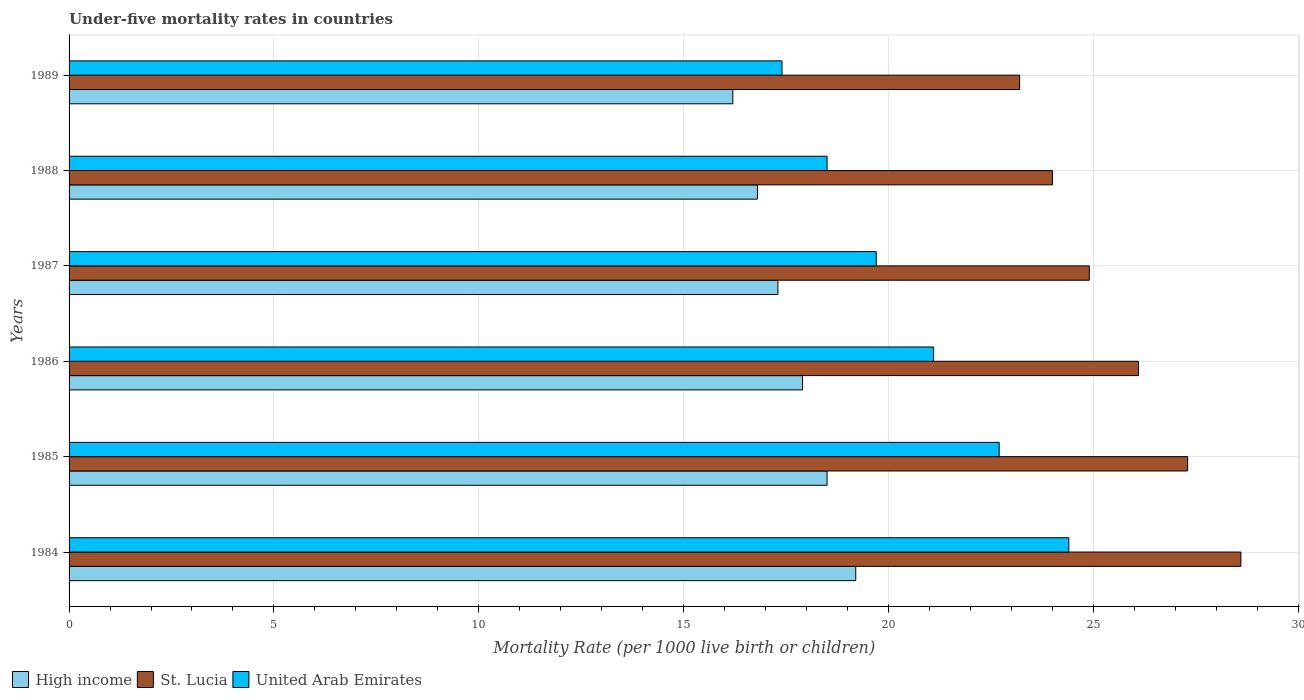Are the number of bars per tick equal to the number of legend labels?
Offer a terse response. Yes. Are the number of bars on each tick of the Y-axis equal?
Offer a very short reply. Yes. How many bars are there on the 4th tick from the top?
Ensure brevity in your answer.  3. In how many cases, is the number of bars for a given year not equal to the number of legend labels?
Your response must be concise. 0. Across all years, what is the maximum under-five mortality rate in St. Lucia?
Your answer should be very brief. 28.6. Across all years, what is the minimum under-five mortality rate in St. Lucia?
Make the answer very short. 23.2. In which year was the under-five mortality rate in High income maximum?
Ensure brevity in your answer.  1984. In which year was the under-five mortality rate in High income minimum?
Provide a succinct answer. 1989. What is the total under-five mortality rate in High income in the graph?
Give a very brief answer. 105.9. What is the difference between the under-five mortality rate in United Arab Emirates in 1986 and that in 1988?
Offer a terse response. 2.6. What is the difference between the under-five mortality rate in St. Lucia in 1987 and the under-five mortality rate in United Arab Emirates in 1988?
Your response must be concise. 6.4. What is the average under-five mortality rate in High income per year?
Keep it short and to the point. 17.65. In the year 1989, what is the difference between the under-five mortality rate in United Arab Emirates and under-five mortality rate in St. Lucia?
Provide a succinct answer. -5.8. In how many years, is the under-five mortality rate in St. Lucia greater than 7 ?
Provide a succinct answer. 6. What is the ratio of the under-five mortality rate in United Arab Emirates in 1984 to that in 1986?
Your answer should be very brief. 1.16. Is the under-five mortality rate in High income in 1984 less than that in 1989?
Your answer should be compact. No. Is the difference between the under-five mortality rate in United Arab Emirates in 1985 and 1988 greater than the difference between the under-five mortality rate in St. Lucia in 1985 and 1988?
Your answer should be compact. Yes. What is the difference between the highest and the second highest under-five mortality rate in High income?
Keep it short and to the point. 0.7. In how many years, is the under-five mortality rate in St. Lucia greater than the average under-five mortality rate in St. Lucia taken over all years?
Provide a short and direct response. 3. Is the sum of the under-five mortality rate in St. Lucia in 1984 and 1986 greater than the maximum under-five mortality rate in United Arab Emirates across all years?
Give a very brief answer. Yes. What does the 1st bar from the top in 1984 represents?
Offer a very short reply. United Arab Emirates. Is it the case that in every year, the sum of the under-five mortality rate in St. Lucia and under-five mortality rate in High income is greater than the under-five mortality rate in United Arab Emirates?
Make the answer very short. Yes. What is the difference between two consecutive major ticks on the X-axis?
Offer a terse response. 5. Does the graph contain any zero values?
Ensure brevity in your answer.  No. Does the graph contain grids?
Provide a succinct answer. Yes. Where does the legend appear in the graph?
Your answer should be compact. Bottom left. How are the legend labels stacked?
Keep it short and to the point. Horizontal. What is the title of the graph?
Keep it short and to the point. Under-five mortality rates in countries. What is the label or title of the X-axis?
Your response must be concise. Mortality Rate (per 1000 live birth or children). What is the label or title of the Y-axis?
Provide a short and direct response. Years. What is the Mortality Rate (per 1000 live birth or children) in St. Lucia in 1984?
Give a very brief answer. 28.6. What is the Mortality Rate (per 1000 live birth or children) in United Arab Emirates in 1984?
Your answer should be compact. 24.4. What is the Mortality Rate (per 1000 live birth or children) of St. Lucia in 1985?
Your answer should be compact. 27.3. What is the Mortality Rate (per 1000 live birth or children) of United Arab Emirates in 1985?
Keep it short and to the point. 22.7. What is the Mortality Rate (per 1000 live birth or children) of St. Lucia in 1986?
Offer a very short reply. 26.1. What is the Mortality Rate (per 1000 live birth or children) in United Arab Emirates in 1986?
Offer a terse response. 21.1. What is the Mortality Rate (per 1000 live birth or children) in St. Lucia in 1987?
Provide a succinct answer. 24.9. What is the Mortality Rate (per 1000 live birth or children) of St. Lucia in 1989?
Ensure brevity in your answer.  23.2. What is the Mortality Rate (per 1000 live birth or children) of United Arab Emirates in 1989?
Make the answer very short. 17.4. Across all years, what is the maximum Mortality Rate (per 1000 live birth or children) in High income?
Offer a very short reply. 19.2. Across all years, what is the maximum Mortality Rate (per 1000 live birth or children) of St. Lucia?
Make the answer very short. 28.6. Across all years, what is the maximum Mortality Rate (per 1000 live birth or children) of United Arab Emirates?
Keep it short and to the point. 24.4. Across all years, what is the minimum Mortality Rate (per 1000 live birth or children) of St. Lucia?
Offer a terse response. 23.2. Across all years, what is the minimum Mortality Rate (per 1000 live birth or children) of United Arab Emirates?
Make the answer very short. 17.4. What is the total Mortality Rate (per 1000 live birth or children) in High income in the graph?
Provide a succinct answer. 105.9. What is the total Mortality Rate (per 1000 live birth or children) in St. Lucia in the graph?
Give a very brief answer. 154.1. What is the total Mortality Rate (per 1000 live birth or children) of United Arab Emirates in the graph?
Make the answer very short. 123.8. What is the difference between the Mortality Rate (per 1000 live birth or children) of United Arab Emirates in 1984 and that in 1985?
Provide a short and direct response. 1.7. What is the difference between the Mortality Rate (per 1000 live birth or children) in High income in 1984 and that in 1986?
Offer a terse response. 1.3. What is the difference between the Mortality Rate (per 1000 live birth or children) of United Arab Emirates in 1984 and that in 1986?
Keep it short and to the point. 3.3. What is the difference between the Mortality Rate (per 1000 live birth or children) in St. Lucia in 1984 and that in 1987?
Your answer should be very brief. 3.7. What is the difference between the Mortality Rate (per 1000 live birth or children) in High income in 1984 and that in 1988?
Give a very brief answer. 2.4. What is the difference between the Mortality Rate (per 1000 live birth or children) in High income in 1984 and that in 1989?
Make the answer very short. 3. What is the difference between the Mortality Rate (per 1000 live birth or children) of High income in 1985 and that in 1986?
Give a very brief answer. 0.6. What is the difference between the Mortality Rate (per 1000 live birth or children) of St. Lucia in 1985 and that in 1986?
Ensure brevity in your answer.  1.2. What is the difference between the Mortality Rate (per 1000 live birth or children) of High income in 1985 and that in 1987?
Offer a very short reply. 1.2. What is the difference between the Mortality Rate (per 1000 live birth or children) of St. Lucia in 1985 and that in 1987?
Offer a terse response. 2.4. What is the difference between the Mortality Rate (per 1000 live birth or children) in United Arab Emirates in 1985 and that in 1987?
Your answer should be compact. 3. What is the difference between the Mortality Rate (per 1000 live birth or children) of High income in 1985 and that in 1988?
Give a very brief answer. 1.7. What is the difference between the Mortality Rate (per 1000 live birth or children) in St. Lucia in 1985 and that in 1988?
Provide a short and direct response. 3.3. What is the difference between the Mortality Rate (per 1000 live birth or children) of United Arab Emirates in 1985 and that in 1988?
Give a very brief answer. 4.2. What is the difference between the Mortality Rate (per 1000 live birth or children) of High income in 1985 and that in 1989?
Provide a short and direct response. 2.3. What is the difference between the Mortality Rate (per 1000 live birth or children) in United Arab Emirates in 1985 and that in 1989?
Your answer should be very brief. 5.3. What is the difference between the Mortality Rate (per 1000 live birth or children) in High income in 1986 and that in 1987?
Ensure brevity in your answer.  0.6. What is the difference between the Mortality Rate (per 1000 live birth or children) of St. Lucia in 1986 and that in 1987?
Offer a terse response. 1.2. What is the difference between the Mortality Rate (per 1000 live birth or children) of United Arab Emirates in 1986 and that in 1987?
Your answer should be very brief. 1.4. What is the difference between the Mortality Rate (per 1000 live birth or children) of St. Lucia in 1986 and that in 1988?
Provide a succinct answer. 2.1. What is the difference between the Mortality Rate (per 1000 live birth or children) of High income in 1986 and that in 1989?
Keep it short and to the point. 1.7. What is the difference between the Mortality Rate (per 1000 live birth or children) of United Arab Emirates in 1986 and that in 1989?
Ensure brevity in your answer.  3.7. What is the difference between the Mortality Rate (per 1000 live birth or children) in St. Lucia in 1987 and that in 1988?
Provide a succinct answer. 0.9. What is the difference between the Mortality Rate (per 1000 live birth or children) in United Arab Emirates in 1987 and that in 1988?
Provide a succinct answer. 1.2. What is the difference between the Mortality Rate (per 1000 live birth or children) in High income in 1984 and the Mortality Rate (per 1000 live birth or children) in United Arab Emirates in 1985?
Give a very brief answer. -3.5. What is the difference between the Mortality Rate (per 1000 live birth or children) in St. Lucia in 1984 and the Mortality Rate (per 1000 live birth or children) in United Arab Emirates in 1985?
Provide a short and direct response. 5.9. What is the difference between the Mortality Rate (per 1000 live birth or children) of High income in 1984 and the Mortality Rate (per 1000 live birth or children) of United Arab Emirates in 1986?
Provide a succinct answer. -1.9. What is the difference between the Mortality Rate (per 1000 live birth or children) in St. Lucia in 1984 and the Mortality Rate (per 1000 live birth or children) in United Arab Emirates in 1986?
Your answer should be compact. 7.5. What is the difference between the Mortality Rate (per 1000 live birth or children) in High income in 1984 and the Mortality Rate (per 1000 live birth or children) in St. Lucia in 1987?
Ensure brevity in your answer.  -5.7. What is the difference between the Mortality Rate (per 1000 live birth or children) in High income in 1984 and the Mortality Rate (per 1000 live birth or children) in United Arab Emirates in 1987?
Make the answer very short. -0.5. What is the difference between the Mortality Rate (per 1000 live birth or children) of St. Lucia in 1984 and the Mortality Rate (per 1000 live birth or children) of United Arab Emirates in 1987?
Ensure brevity in your answer.  8.9. What is the difference between the Mortality Rate (per 1000 live birth or children) in High income in 1984 and the Mortality Rate (per 1000 live birth or children) in St. Lucia in 1988?
Your answer should be compact. -4.8. What is the difference between the Mortality Rate (per 1000 live birth or children) in High income in 1984 and the Mortality Rate (per 1000 live birth or children) in St. Lucia in 1989?
Make the answer very short. -4. What is the difference between the Mortality Rate (per 1000 live birth or children) in High income in 1984 and the Mortality Rate (per 1000 live birth or children) in United Arab Emirates in 1989?
Give a very brief answer. 1.8. What is the difference between the Mortality Rate (per 1000 live birth or children) in St. Lucia in 1984 and the Mortality Rate (per 1000 live birth or children) in United Arab Emirates in 1989?
Offer a very short reply. 11.2. What is the difference between the Mortality Rate (per 1000 live birth or children) in High income in 1985 and the Mortality Rate (per 1000 live birth or children) in St. Lucia in 1986?
Provide a succinct answer. -7.6. What is the difference between the Mortality Rate (per 1000 live birth or children) in High income in 1985 and the Mortality Rate (per 1000 live birth or children) in United Arab Emirates in 1987?
Your answer should be very brief. -1.2. What is the difference between the Mortality Rate (per 1000 live birth or children) of St. Lucia in 1985 and the Mortality Rate (per 1000 live birth or children) of United Arab Emirates in 1987?
Give a very brief answer. 7.6. What is the difference between the Mortality Rate (per 1000 live birth or children) of High income in 1985 and the Mortality Rate (per 1000 live birth or children) of St. Lucia in 1988?
Keep it short and to the point. -5.5. What is the difference between the Mortality Rate (per 1000 live birth or children) of St. Lucia in 1985 and the Mortality Rate (per 1000 live birth or children) of United Arab Emirates in 1988?
Offer a terse response. 8.8. What is the difference between the Mortality Rate (per 1000 live birth or children) of High income in 1985 and the Mortality Rate (per 1000 live birth or children) of St. Lucia in 1989?
Offer a very short reply. -4.7. What is the difference between the Mortality Rate (per 1000 live birth or children) in St. Lucia in 1985 and the Mortality Rate (per 1000 live birth or children) in United Arab Emirates in 1989?
Offer a very short reply. 9.9. What is the difference between the Mortality Rate (per 1000 live birth or children) in High income in 1986 and the Mortality Rate (per 1000 live birth or children) in St. Lucia in 1987?
Make the answer very short. -7. What is the difference between the Mortality Rate (per 1000 live birth or children) of High income in 1986 and the Mortality Rate (per 1000 live birth or children) of United Arab Emirates in 1987?
Provide a short and direct response. -1.8. What is the difference between the Mortality Rate (per 1000 live birth or children) of High income in 1986 and the Mortality Rate (per 1000 live birth or children) of St. Lucia in 1988?
Make the answer very short. -6.1. What is the difference between the Mortality Rate (per 1000 live birth or children) in St. Lucia in 1986 and the Mortality Rate (per 1000 live birth or children) in United Arab Emirates in 1988?
Offer a very short reply. 7.6. What is the difference between the Mortality Rate (per 1000 live birth or children) of St. Lucia in 1986 and the Mortality Rate (per 1000 live birth or children) of United Arab Emirates in 1989?
Provide a short and direct response. 8.7. What is the difference between the Mortality Rate (per 1000 live birth or children) in High income in 1987 and the Mortality Rate (per 1000 live birth or children) in St. Lucia in 1988?
Make the answer very short. -6.7. What is the difference between the Mortality Rate (per 1000 live birth or children) of High income in 1987 and the Mortality Rate (per 1000 live birth or children) of United Arab Emirates in 1988?
Give a very brief answer. -1.2. What is the difference between the Mortality Rate (per 1000 live birth or children) of St. Lucia in 1987 and the Mortality Rate (per 1000 live birth or children) of United Arab Emirates in 1989?
Your answer should be compact. 7.5. What is the difference between the Mortality Rate (per 1000 live birth or children) of High income in 1988 and the Mortality Rate (per 1000 live birth or children) of United Arab Emirates in 1989?
Offer a terse response. -0.6. What is the difference between the Mortality Rate (per 1000 live birth or children) of St. Lucia in 1988 and the Mortality Rate (per 1000 live birth or children) of United Arab Emirates in 1989?
Ensure brevity in your answer.  6.6. What is the average Mortality Rate (per 1000 live birth or children) of High income per year?
Offer a very short reply. 17.65. What is the average Mortality Rate (per 1000 live birth or children) of St. Lucia per year?
Your answer should be very brief. 25.68. What is the average Mortality Rate (per 1000 live birth or children) of United Arab Emirates per year?
Provide a succinct answer. 20.63. In the year 1984, what is the difference between the Mortality Rate (per 1000 live birth or children) of High income and Mortality Rate (per 1000 live birth or children) of St. Lucia?
Provide a succinct answer. -9.4. In the year 1985, what is the difference between the Mortality Rate (per 1000 live birth or children) of St. Lucia and Mortality Rate (per 1000 live birth or children) of United Arab Emirates?
Provide a short and direct response. 4.6. In the year 1986, what is the difference between the Mortality Rate (per 1000 live birth or children) in High income and Mortality Rate (per 1000 live birth or children) in St. Lucia?
Offer a terse response. -8.2. In the year 1986, what is the difference between the Mortality Rate (per 1000 live birth or children) of St. Lucia and Mortality Rate (per 1000 live birth or children) of United Arab Emirates?
Offer a very short reply. 5. In the year 1987, what is the difference between the Mortality Rate (per 1000 live birth or children) in High income and Mortality Rate (per 1000 live birth or children) in United Arab Emirates?
Your answer should be very brief. -2.4. In the year 1987, what is the difference between the Mortality Rate (per 1000 live birth or children) in St. Lucia and Mortality Rate (per 1000 live birth or children) in United Arab Emirates?
Offer a terse response. 5.2. In the year 1988, what is the difference between the Mortality Rate (per 1000 live birth or children) in High income and Mortality Rate (per 1000 live birth or children) in St. Lucia?
Provide a short and direct response. -7.2. In the year 1988, what is the difference between the Mortality Rate (per 1000 live birth or children) of High income and Mortality Rate (per 1000 live birth or children) of United Arab Emirates?
Your answer should be compact. -1.7. In the year 1988, what is the difference between the Mortality Rate (per 1000 live birth or children) in St. Lucia and Mortality Rate (per 1000 live birth or children) in United Arab Emirates?
Provide a short and direct response. 5.5. In the year 1989, what is the difference between the Mortality Rate (per 1000 live birth or children) in High income and Mortality Rate (per 1000 live birth or children) in United Arab Emirates?
Your answer should be compact. -1.2. In the year 1989, what is the difference between the Mortality Rate (per 1000 live birth or children) in St. Lucia and Mortality Rate (per 1000 live birth or children) in United Arab Emirates?
Ensure brevity in your answer.  5.8. What is the ratio of the Mortality Rate (per 1000 live birth or children) in High income in 1984 to that in 1985?
Ensure brevity in your answer.  1.04. What is the ratio of the Mortality Rate (per 1000 live birth or children) of St. Lucia in 1984 to that in 1985?
Your response must be concise. 1.05. What is the ratio of the Mortality Rate (per 1000 live birth or children) of United Arab Emirates in 1984 to that in 1985?
Your answer should be very brief. 1.07. What is the ratio of the Mortality Rate (per 1000 live birth or children) in High income in 1984 to that in 1986?
Offer a very short reply. 1.07. What is the ratio of the Mortality Rate (per 1000 live birth or children) of St. Lucia in 1984 to that in 1986?
Your answer should be compact. 1.1. What is the ratio of the Mortality Rate (per 1000 live birth or children) of United Arab Emirates in 1984 to that in 1986?
Your answer should be very brief. 1.16. What is the ratio of the Mortality Rate (per 1000 live birth or children) of High income in 1984 to that in 1987?
Offer a terse response. 1.11. What is the ratio of the Mortality Rate (per 1000 live birth or children) of St. Lucia in 1984 to that in 1987?
Offer a terse response. 1.15. What is the ratio of the Mortality Rate (per 1000 live birth or children) in United Arab Emirates in 1984 to that in 1987?
Your answer should be compact. 1.24. What is the ratio of the Mortality Rate (per 1000 live birth or children) in High income in 1984 to that in 1988?
Provide a succinct answer. 1.14. What is the ratio of the Mortality Rate (per 1000 live birth or children) in St. Lucia in 1984 to that in 1988?
Your response must be concise. 1.19. What is the ratio of the Mortality Rate (per 1000 live birth or children) of United Arab Emirates in 1984 to that in 1988?
Make the answer very short. 1.32. What is the ratio of the Mortality Rate (per 1000 live birth or children) in High income in 1984 to that in 1989?
Offer a terse response. 1.19. What is the ratio of the Mortality Rate (per 1000 live birth or children) in St. Lucia in 1984 to that in 1989?
Provide a short and direct response. 1.23. What is the ratio of the Mortality Rate (per 1000 live birth or children) in United Arab Emirates in 1984 to that in 1989?
Your answer should be very brief. 1.4. What is the ratio of the Mortality Rate (per 1000 live birth or children) of High income in 1985 to that in 1986?
Offer a very short reply. 1.03. What is the ratio of the Mortality Rate (per 1000 live birth or children) in St. Lucia in 1985 to that in 1986?
Give a very brief answer. 1.05. What is the ratio of the Mortality Rate (per 1000 live birth or children) of United Arab Emirates in 1985 to that in 1986?
Provide a succinct answer. 1.08. What is the ratio of the Mortality Rate (per 1000 live birth or children) of High income in 1985 to that in 1987?
Your answer should be compact. 1.07. What is the ratio of the Mortality Rate (per 1000 live birth or children) in St. Lucia in 1985 to that in 1987?
Provide a short and direct response. 1.1. What is the ratio of the Mortality Rate (per 1000 live birth or children) in United Arab Emirates in 1985 to that in 1987?
Make the answer very short. 1.15. What is the ratio of the Mortality Rate (per 1000 live birth or children) of High income in 1985 to that in 1988?
Provide a succinct answer. 1.1. What is the ratio of the Mortality Rate (per 1000 live birth or children) of St. Lucia in 1985 to that in 1988?
Make the answer very short. 1.14. What is the ratio of the Mortality Rate (per 1000 live birth or children) in United Arab Emirates in 1985 to that in 1988?
Provide a short and direct response. 1.23. What is the ratio of the Mortality Rate (per 1000 live birth or children) of High income in 1985 to that in 1989?
Provide a short and direct response. 1.14. What is the ratio of the Mortality Rate (per 1000 live birth or children) in St. Lucia in 1985 to that in 1989?
Offer a terse response. 1.18. What is the ratio of the Mortality Rate (per 1000 live birth or children) in United Arab Emirates in 1985 to that in 1989?
Provide a succinct answer. 1.3. What is the ratio of the Mortality Rate (per 1000 live birth or children) in High income in 1986 to that in 1987?
Your answer should be very brief. 1.03. What is the ratio of the Mortality Rate (per 1000 live birth or children) in St. Lucia in 1986 to that in 1987?
Your answer should be very brief. 1.05. What is the ratio of the Mortality Rate (per 1000 live birth or children) in United Arab Emirates in 1986 to that in 1987?
Keep it short and to the point. 1.07. What is the ratio of the Mortality Rate (per 1000 live birth or children) in High income in 1986 to that in 1988?
Offer a very short reply. 1.07. What is the ratio of the Mortality Rate (per 1000 live birth or children) in St. Lucia in 1986 to that in 1988?
Keep it short and to the point. 1.09. What is the ratio of the Mortality Rate (per 1000 live birth or children) in United Arab Emirates in 1986 to that in 1988?
Offer a terse response. 1.14. What is the ratio of the Mortality Rate (per 1000 live birth or children) of High income in 1986 to that in 1989?
Provide a short and direct response. 1.1. What is the ratio of the Mortality Rate (per 1000 live birth or children) of St. Lucia in 1986 to that in 1989?
Ensure brevity in your answer.  1.12. What is the ratio of the Mortality Rate (per 1000 live birth or children) of United Arab Emirates in 1986 to that in 1989?
Offer a very short reply. 1.21. What is the ratio of the Mortality Rate (per 1000 live birth or children) in High income in 1987 to that in 1988?
Offer a very short reply. 1.03. What is the ratio of the Mortality Rate (per 1000 live birth or children) of St. Lucia in 1987 to that in 1988?
Provide a succinct answer. 1.04. What is the ratio of the Mortality Rate (per 1000 live birth or children) of United Arab Emirates in 1987 to that in 1988?
Offer a very short reply. 1.06. What is the ratio of the Mortality Rate (per 1000 live birth or children) of High income in 1987 to that in 1989?
Your answer should be compact. 1.07. What is the ratio of the Mortality Rate (per 1000 live birth or children) of St. Lucia in 1987 to that in 1989?
Your answer should be very brief. 1.07. What is the ratio of the Mortality Rate (per 1000 live birth or children) of United Arab Emirates in 1987 to that in 1989?
Make the answer very short. 1.13. What is the ratio of the Mortality Rate (per 1000 live birth or children) of St. Lucia in 1988 to that in 1989?
Make the answer very short. 1.03. What is the ratio of the Mortality Rate (per 1000 live birth or children) of United Arab Emirates in 1988 to that in 1989?
Give a very brief answer. 1.06. What is the difference between the highest and the second highest Mortality Rate (per 1000 live birth or children) in St. Lucia?
Your answer should be very brief. 1.3. What is the difference between the highest and the lowest Mortality Rate (per 1000 live birth or children) of High income?
Ensure brevity in your answer.  3. What is the difference between the highest and the lowest Mortality Rate (per 1000 live birth or children) of United Arab Emirates?
Offer a very short reply. 7. 